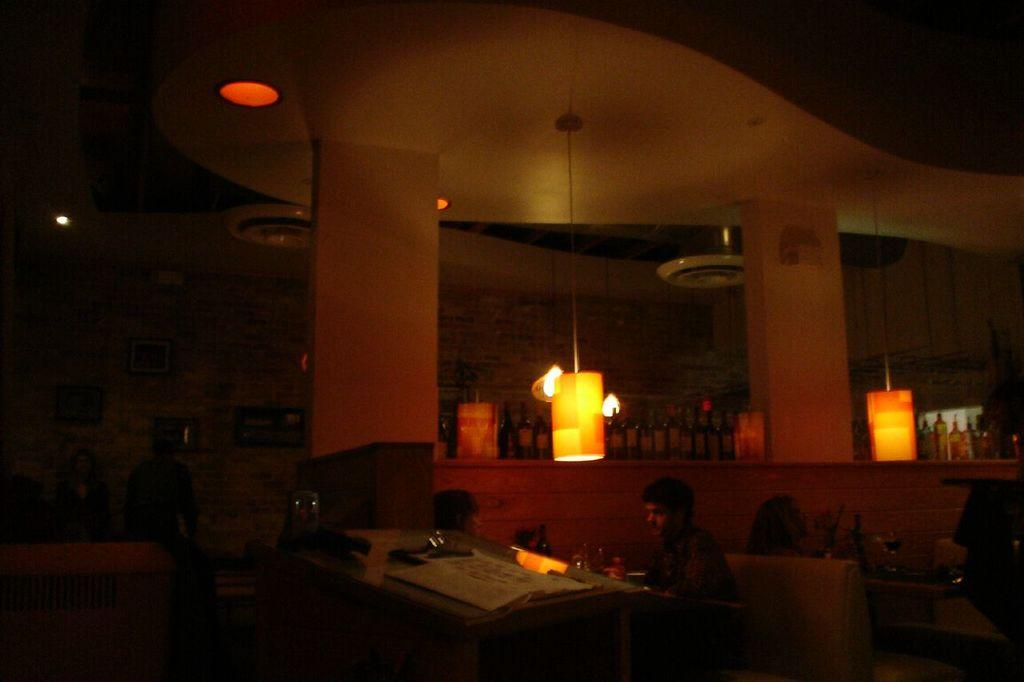How many people are in the image? There is a group of people in the image. What is the condition of the people in the image? The people appear to be sweating. What can be seen in the background of the image? There are lights and bottles in racks visible in the background of the image. What is on the table in the image? There is a paper on a table in the image. What type of temper is the apparatus in the image displaying? There is no apparatus present in the image, and therefore no temper can be observed. 